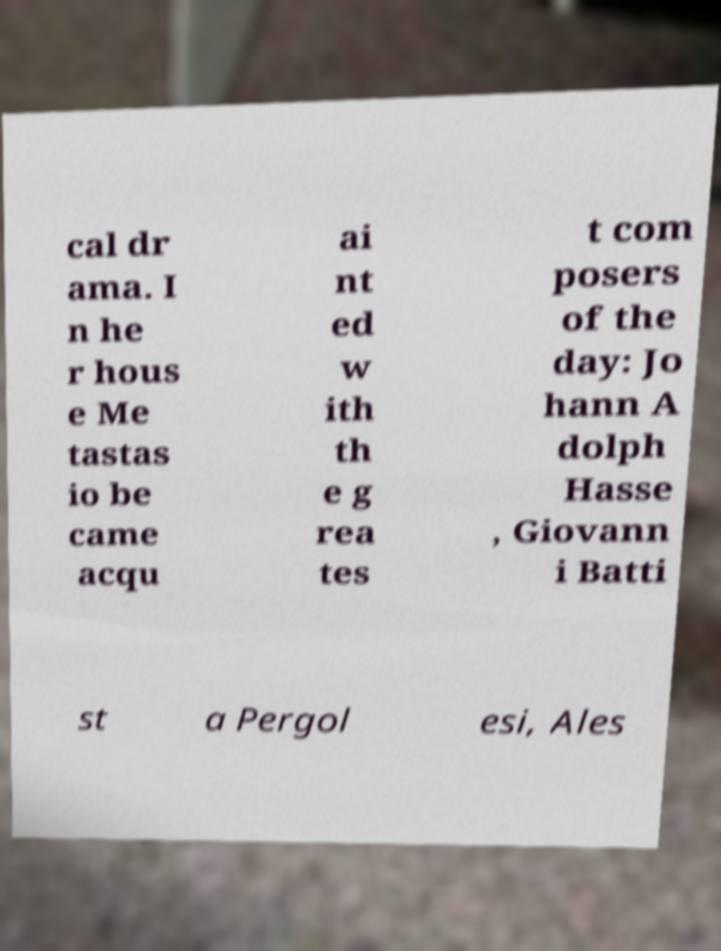Can you accurately transcribe the text from the provided image for me? cal dr ama. I n he r hous e Me tastas io be came acqu ai nt ed w ith th e g rea tes t com posers of the day: Jo hann A dolph Hasse , Giovann i Batti st a Pergol esi, Ales 